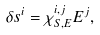<formula> <loc_0><loc_0><loc_500><loc_500>\delta s ^ { i } = \chi ^ { i , j } _ { S , E } E ^ { j } ,</formula> 